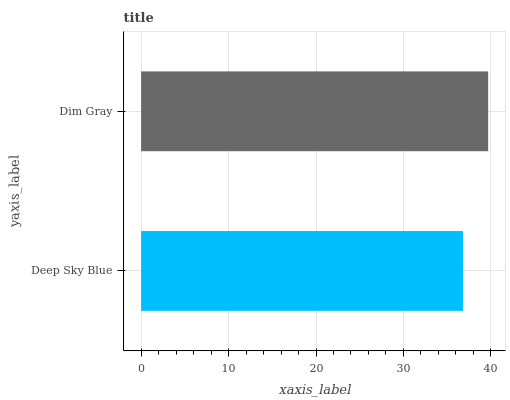Is Deep Sky Blue the minimum?
Answer yes or no. Yes. Is Dim Gray the maximum?
Answer yes or no. Yes. Is Dim Gray the minimum?
Answer yes or no. No. Is Dim Gray greater than Deep Sky Blue?
Answer yes or no. Yes. Is Deep Sky Blue less than Dim Gray?
Answer yes or no. Yes. Is Deep Sky Blue greater than Dim Gray?
Answer yes or no. No. Is Dim Gray less than Deep Sky Blue?
Answer yes or no. No. Is Dim Gray the high median?
Answer yes or no. Yes. Is Deep Sky Blue the low median?
Answer yes or no. Yes. Is Deep Sky Blue the high median?
Answer yes or no. No. Is Dim Gray the low median?
Answer yes or no. No. 